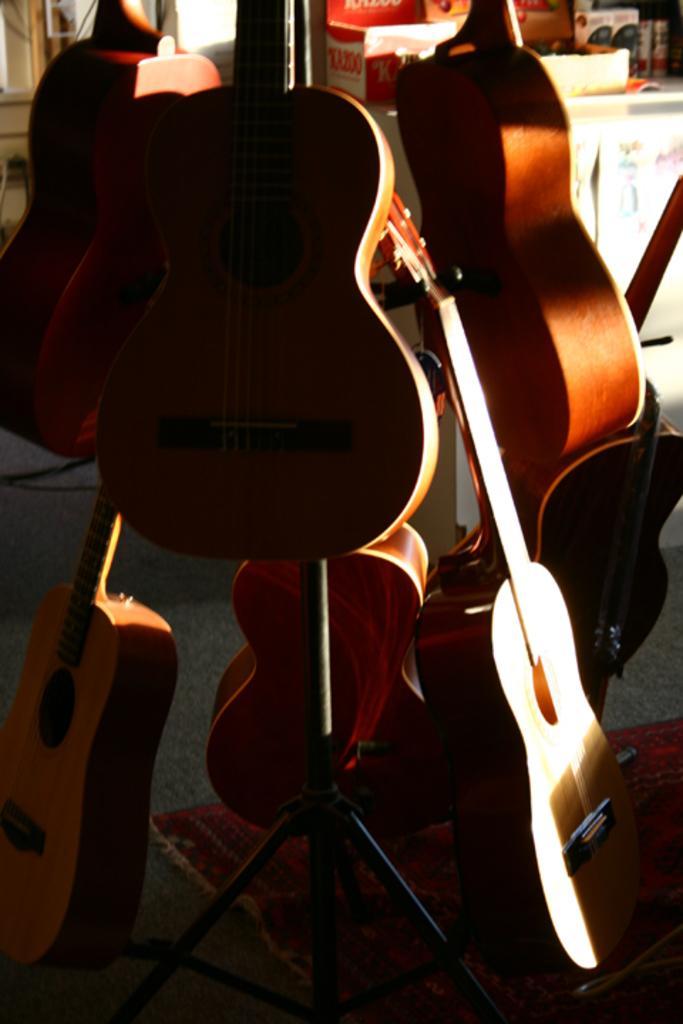Please provide a concise description of this image. As we can see in the image there are lots of guitars over here and there is a table. On table there are boxes. 